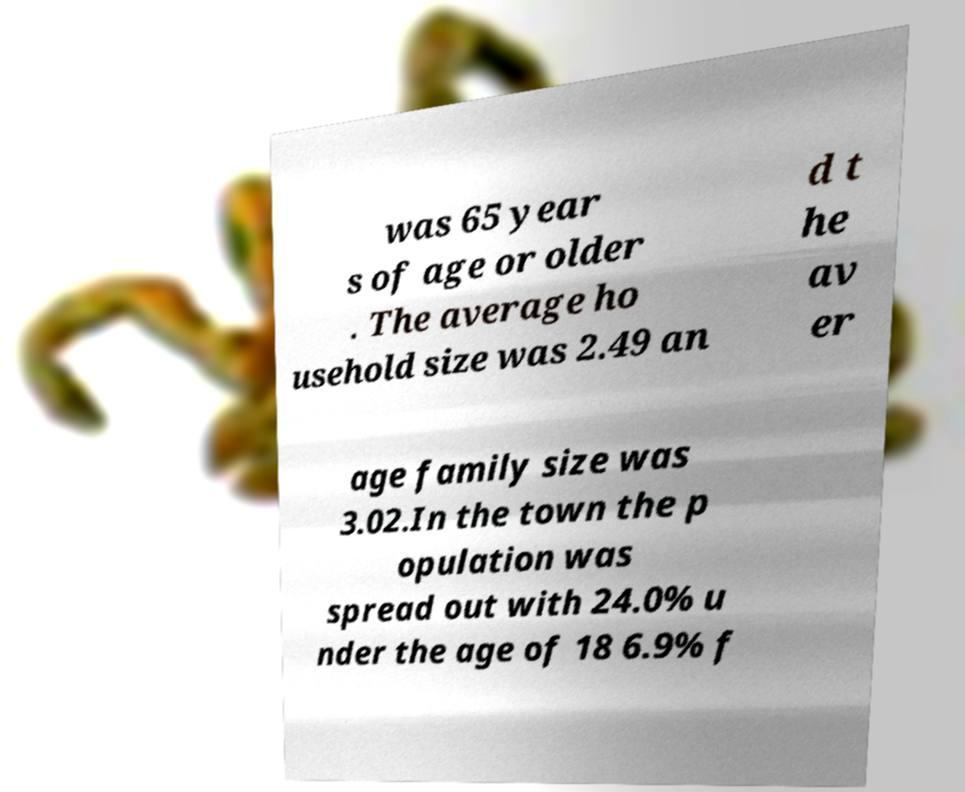Could you extract and type out the text from this image? was 65 year s of age or older . The average ho usehold size was 2.49 an d t he av er age family size was 3.02.In the town the p opulation was spread out with 24.0% u nder the age of 18 6.9% f 